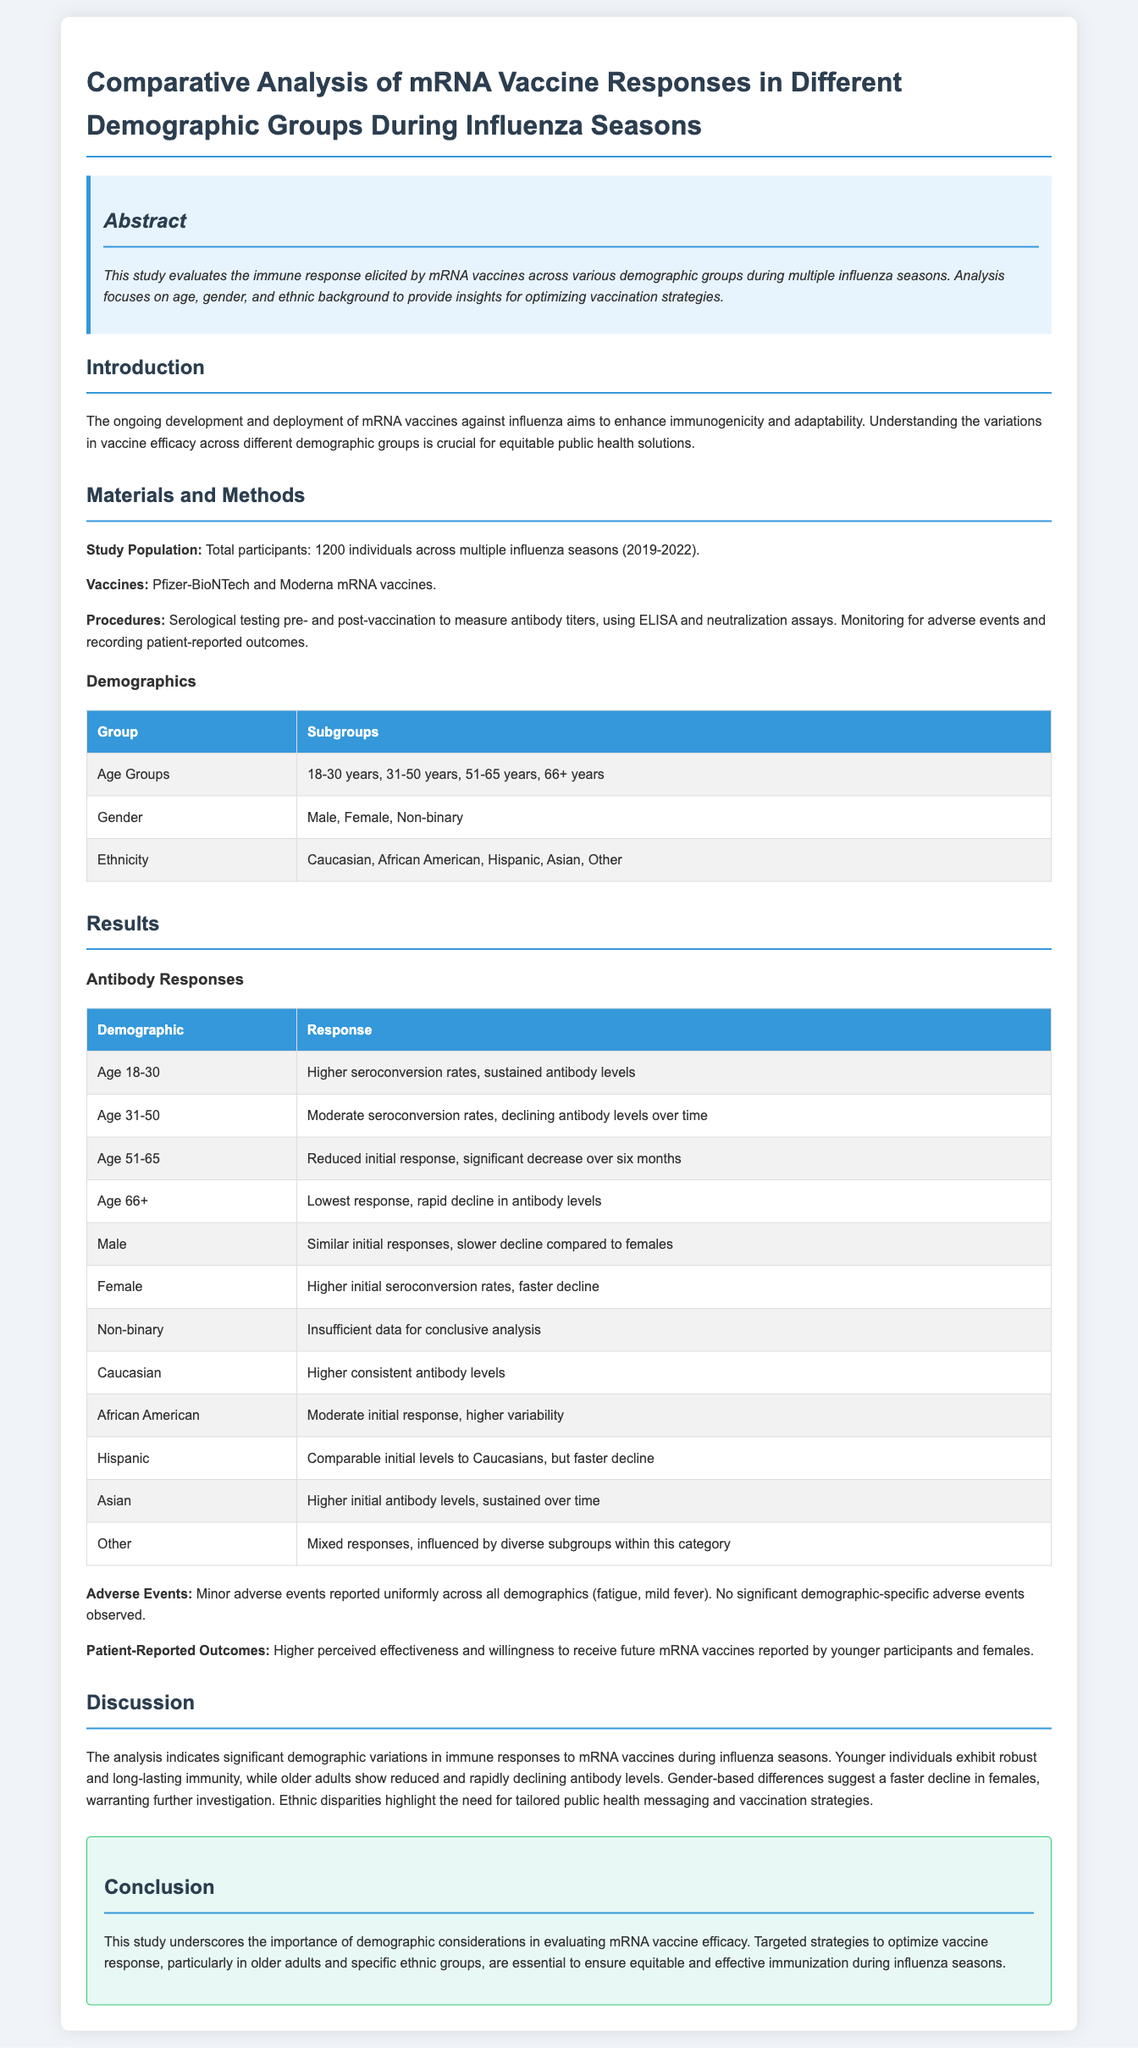What is the total number of participants in the study? The total number of participants is stated in the "Materials and Methods" section, which mentions 1200 individuals.
Answer: 1200 Which age group showed the highest seroconversion rates? The results indicate that the age group 18-30 years had higher seroconversion rates.
Answer: Age 18-30 What were the minor adverse events reported? The report specifies fatigue and mild fever as minor adverse events.
Answer: Fatigue, mild fever What type of vaccines were evaluated in the study? The "Vaccines" section lists the vaccines as Pfizer-BioNTech and Moderna mRNA vaccines.
Answer: Pfizer-BioNTech and Moderna Which gender exhibited a faster decline in antibody levels? The results indicate that females have a faster decline in antibody levels compared to males.
Answer: Females What is the conclusion regarding demographic considerations? The conclusion emphasizes the importance of demographic considerations in evaluating mRNA vaccine efficacy.
Answer: Importance of demographic considerations How did the antibody levels of the Asian demographic compare to others? The results show that the Asian demographic had higher initial antibody levels that were sustained over time.
Answer: Higher initial antibody levels, sustained over time What was the purpose of this study? The abstract states the study's purpose is to evaluate immune response elicited by mRNA vaccines across various demographic groups.
Answer: Evaluate immune response elicited by mRNA vaccines across various demographic groups 